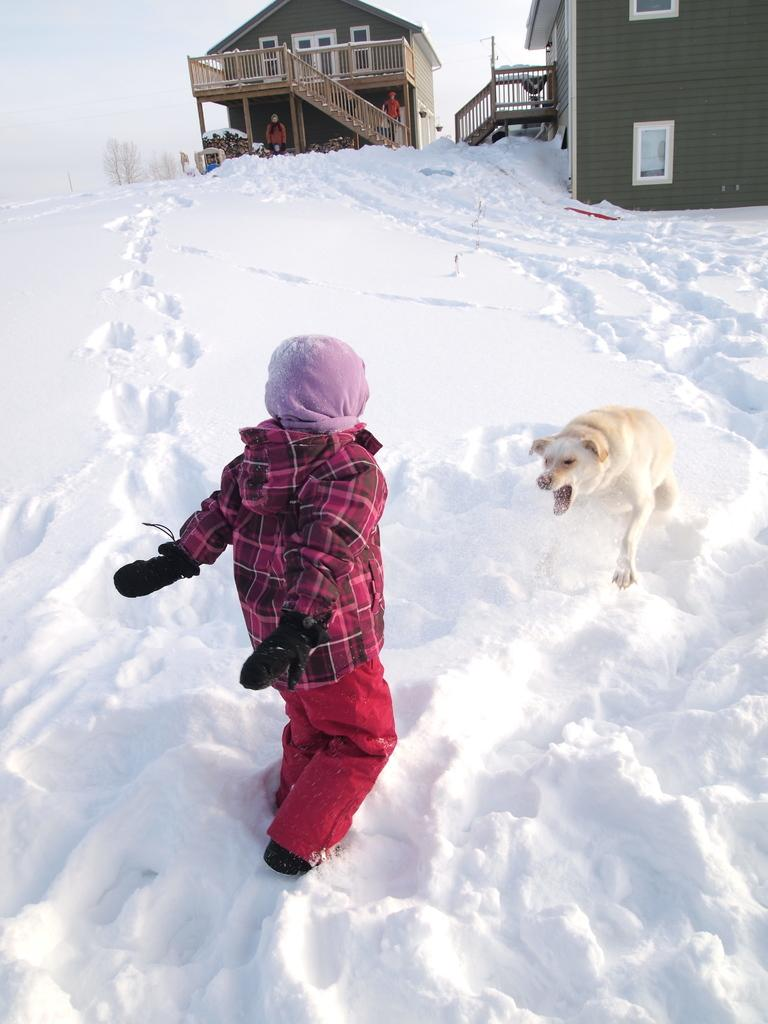What animal can be seen in the image? There is a dog in the image. What is the dog doing in the image? The dog is barking at a boy. Who is the dog barking at? The dog is barking at a boy. What is the boy doing in the image? The boy is standing. Who is observing the interaction between the dog and the boy? Two persons are looking at the boy and the dog. What type of structures can be seen in the background of the image? There are two houses in the image. What type of vegetation is present in the image? Multiple trees are present in the image. What type of passenger can be seen in the image? There is no passenger present in the image. What sound is the dog making in the image? The dog is barking, which is a vocalization, not a sound. 